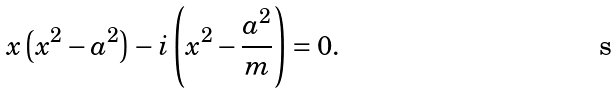<formula> <loc_0><loc_0><loc_500><loc_500>x \left ( x ^ { 2 } - a ^ { 2 } \right ) - i \left ( x ^ { 2 } - \frac { a ^ { 2 } } { m } \right ) = 0 .</formula> 